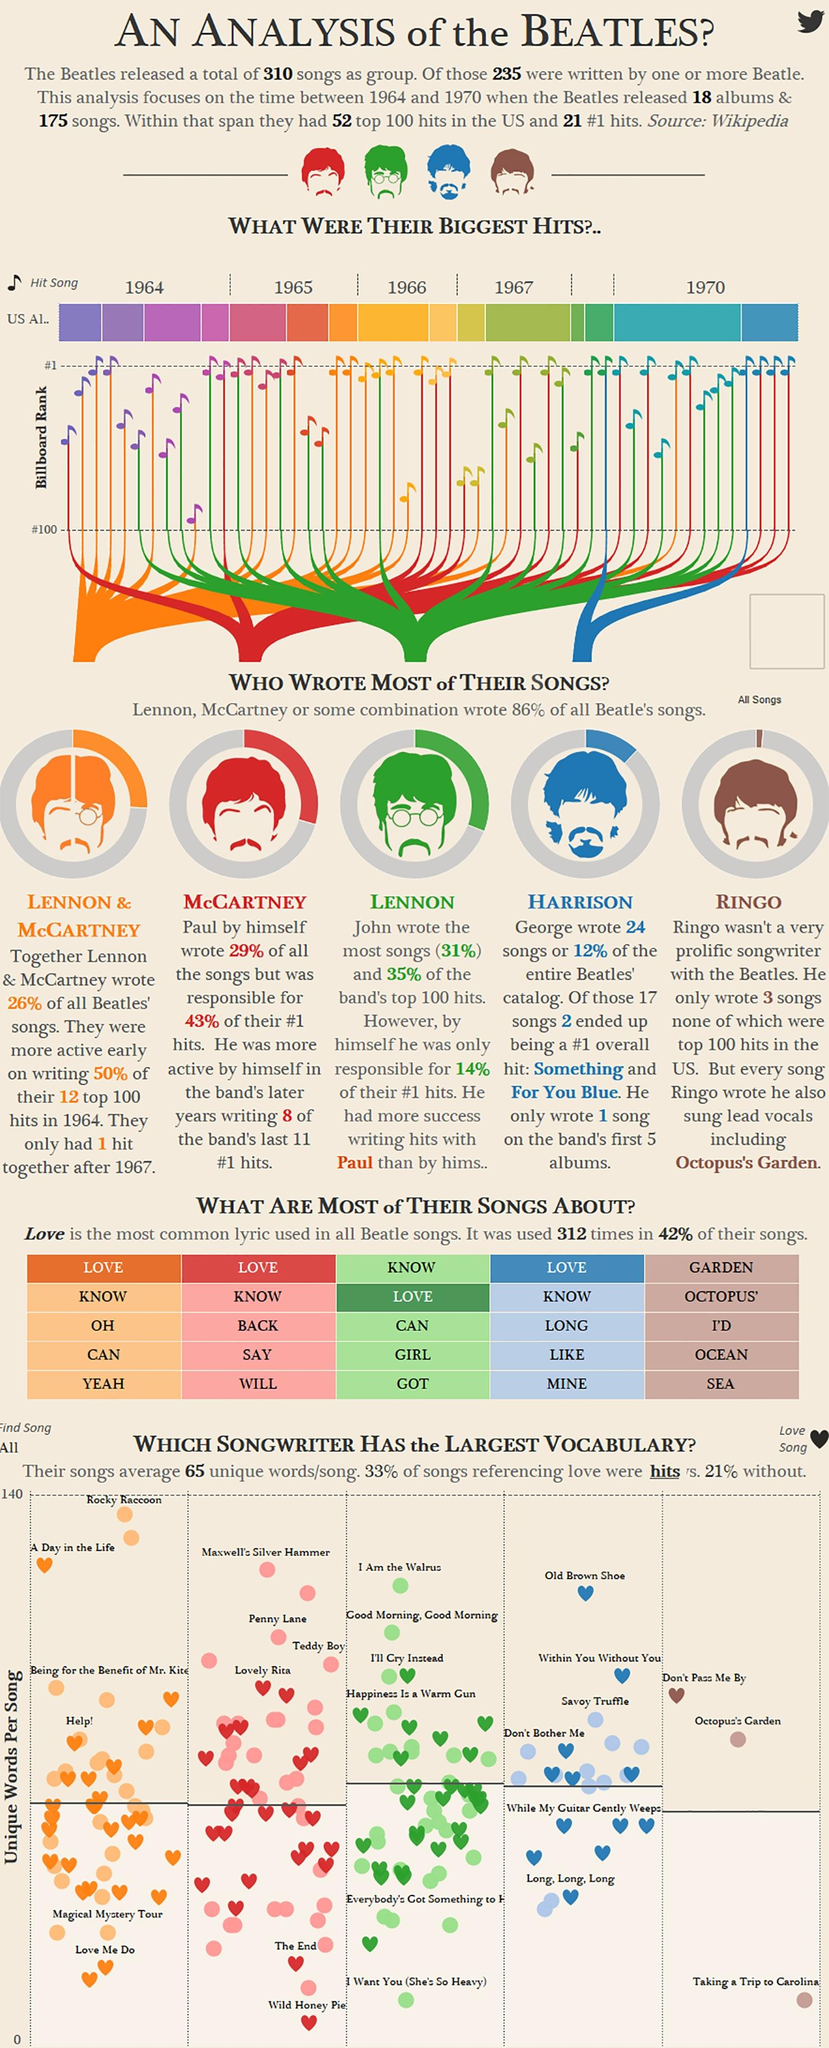List a handful of essential elements in this visual. The band's songs written by Lennon & McCartney together accounted for 26% of their total compositions. Ringo Starr wrote the lowest number of songs. Sir Paul McCartney was responsible for 43% of the Beatles' #1 hits. The person who wrote the songs "Something" and "For You Blue" is George. Ringo Starr wrote the song "Octopus's Garden. 